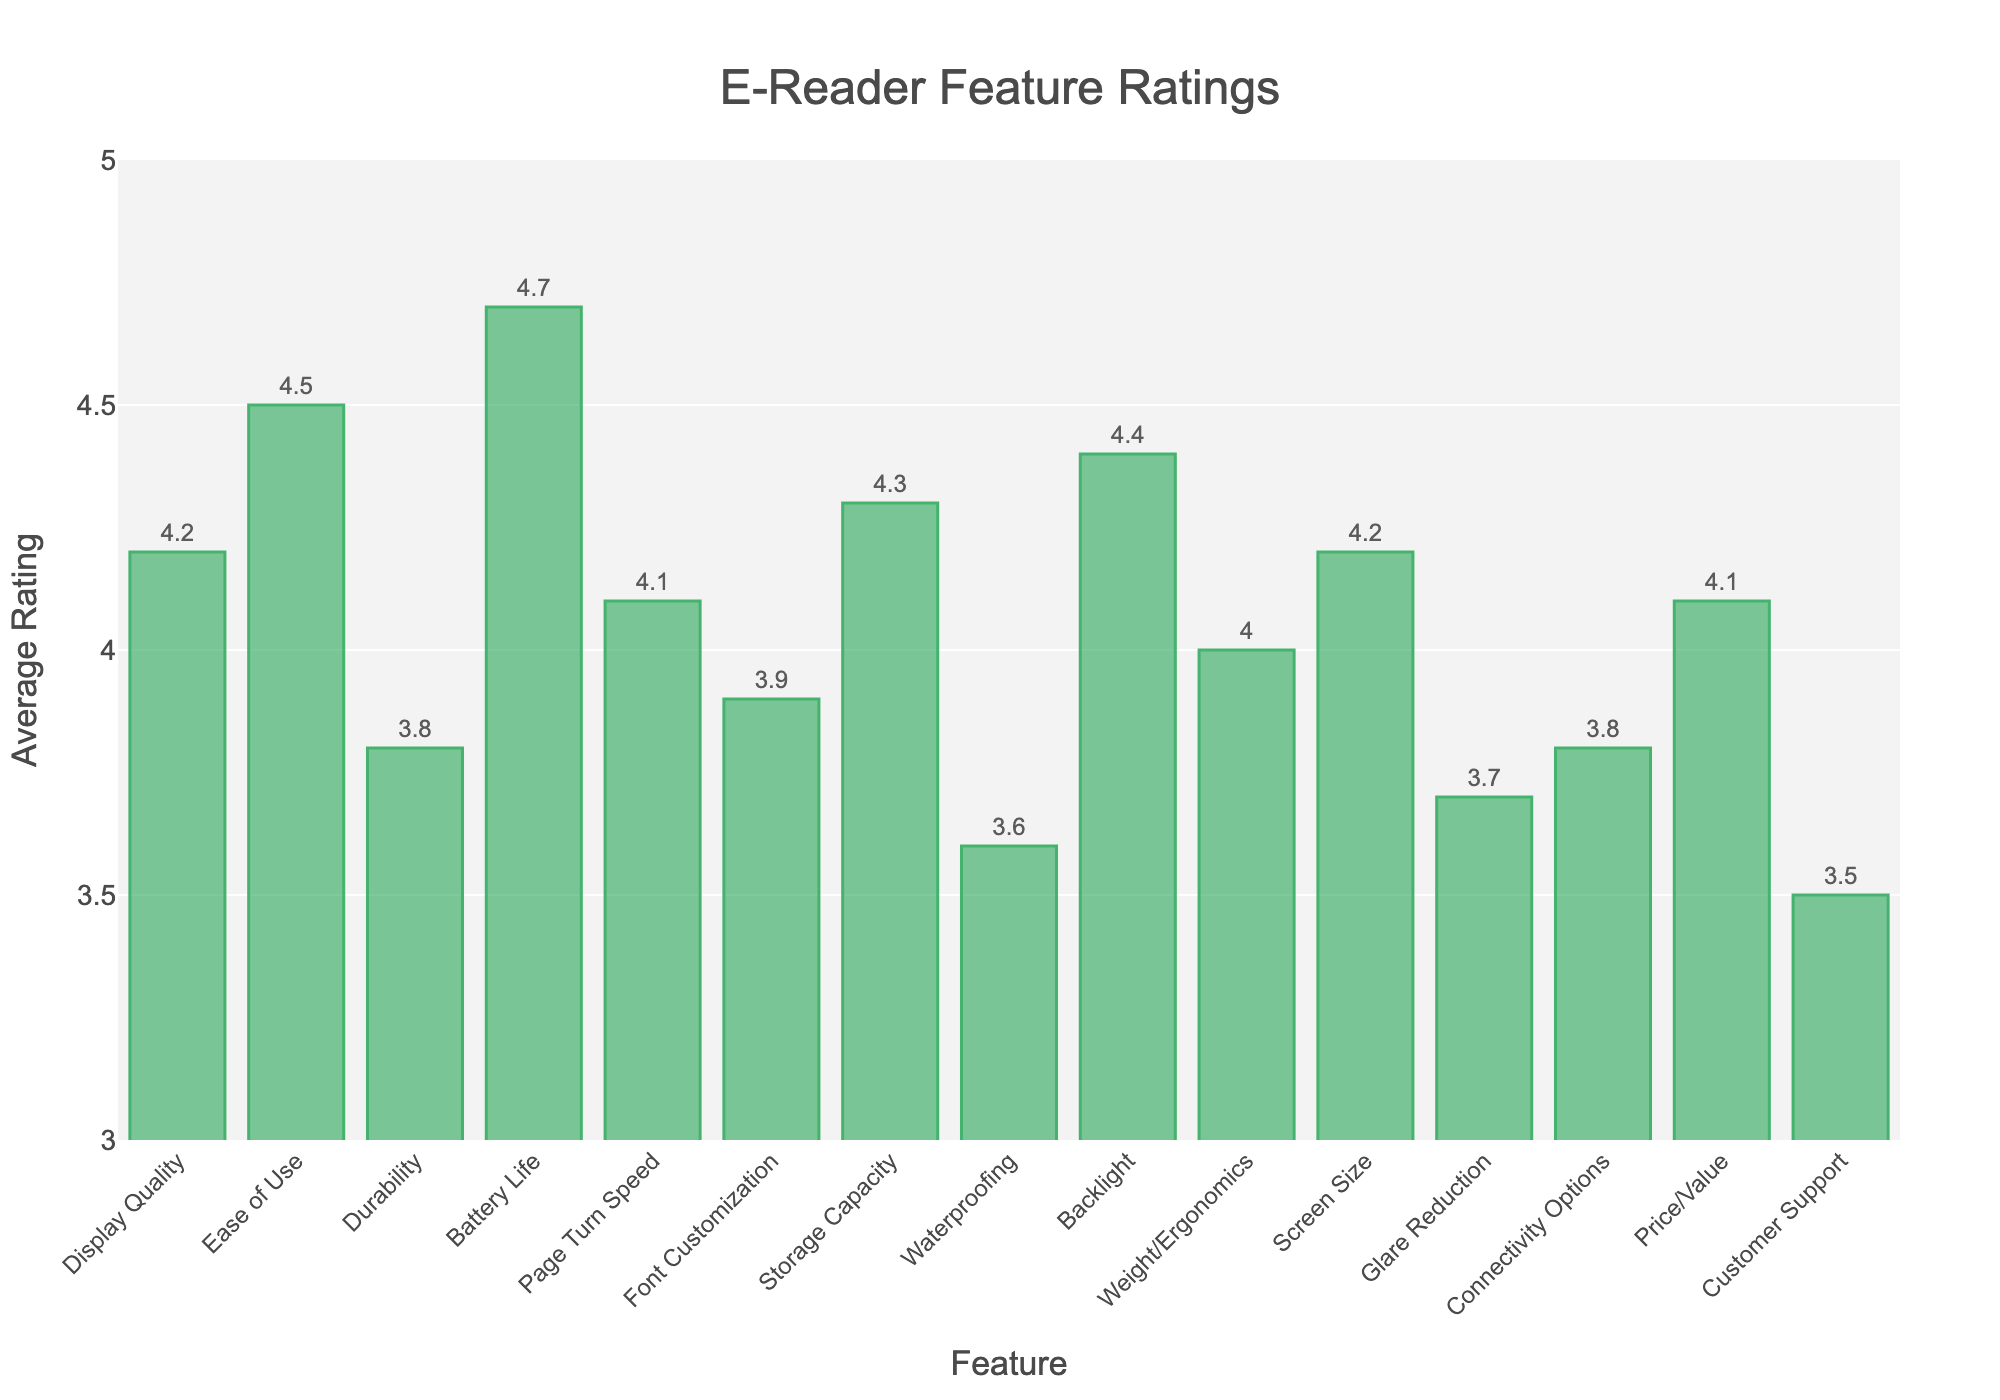What feature has the highest average rating? To determine the feature with the highest average rating, look at the bar heights in the chart and identify the tallest one. The tallest bar represents "Battery Life" with an average rating of 4.7.
Answer: Battery Life Which feature has the lowest average rating? To find the feature with the lowest average rating, identify the shortest bar in the chart. The shortest bar corresponds to "Customer Support" with an average rating of 3.5.
Answer: Customer Support How much higher is the average rating of "Display Quality" compared to "Durability"? Find the average ratings for "Display Quality" (4.2) and "Durability" (3.8). Then subtract the lower rating from the higher one: 4.2 - 3.8 = 0.4.
Answer: 0.4 Which features have an average rating greater than 4.0? Identify bars with heights greater than 4.0. These correspond to "Display Quality," "Ease of Use," "Battery Life," "Storage Capacity," "Backlight," and "Price/Value."
Answer: Display Quality, Ease of Use, Battery Life, Storage Capacity, Backlight, Price/Value What is the combined average rating of "Page Turn Speed" and "Weight/Ergonomics"? Find the average ratings for "Page Turn Speed" (4.1) and "Weight/Ergonomics" (4.0). Add these ratings together: 4.1 + 4.0 = 8.1.
Answer: 8.1 Which feature with an average rating below 4.0 is closest to 4.0? Identify bars with heights below 4.0 and find the one closest to but not exceeding 4.0. The closest feature is "Font Customization" with an average rating of 3.9.
Answer: Font Customization How does the average rating of "Glare Reduction" compare to "Waterproofing"? Compare the heights of the bars for "Glare Reduction" (3.7) and "Waterproofing" (3.6). "Glare Reduction" has a higher average rating than "Waterproofing."
Answer: Glare Reduction What is the difference between the highest and lowest average ratings? Find the highest rating (Battery Life at 4.7) and the lowest rating (Customer Support at 3.5). Subtract the lowest from the highest: 4.7 - 3.5 = 1.2.
Answer: 1.2 Are there more features with ratings above or below 4.0? Count the number of features with ratings above 4.0 and those below 4.0. There are 6 features above 4.0 and 9 features below 4.0.
Answer: Below 4.0 